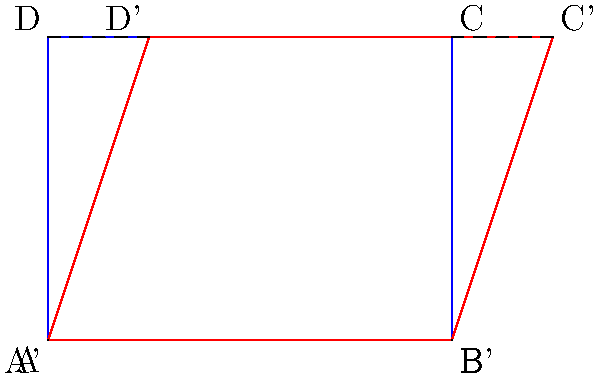For a magic trick illusion, you need to shear a rectangular stage backdrop to create a perspective effect. The original backdrop ABCD (blue) is 4 units wide and 3 units tall. After shearing, the top edge of the backdrop is shifted 1 unit to the right, creating the new shape A'B'C'D' (red). What is the shear factor (h) applied to this transformation? To find the shear factor (h), we need to follow these steps:

1) In a horizontal shear transformation, the x-coordinates change while the y-coordinates remain the same. The transformation is given by:
   $x' = x + hy$
   $y' = y$

2) We can see that points A and B (bottom edge) don't move, so we'll focus on the top edge (DC to D'C').

3) For point D:
   Original: D(0,3)
   Transformed: D'(1,3)
   
   Using the shear equation:
   $1 = 0 + h(3)$

4) Solving for h:
   $h = \frac{1}{3}$

5) We can verify this with point C:
   Original: C(4,3)
   Transformed: C'(5,3)
   
   $5 = 4 + \frac{1}{3}(3)$
   $5 = 4 + 1$
   
   This confirms our calculation.

Therefore, the shear factor (h) is $\frac{1}{3}$.
Answer: $\frac{1}{3}$ 